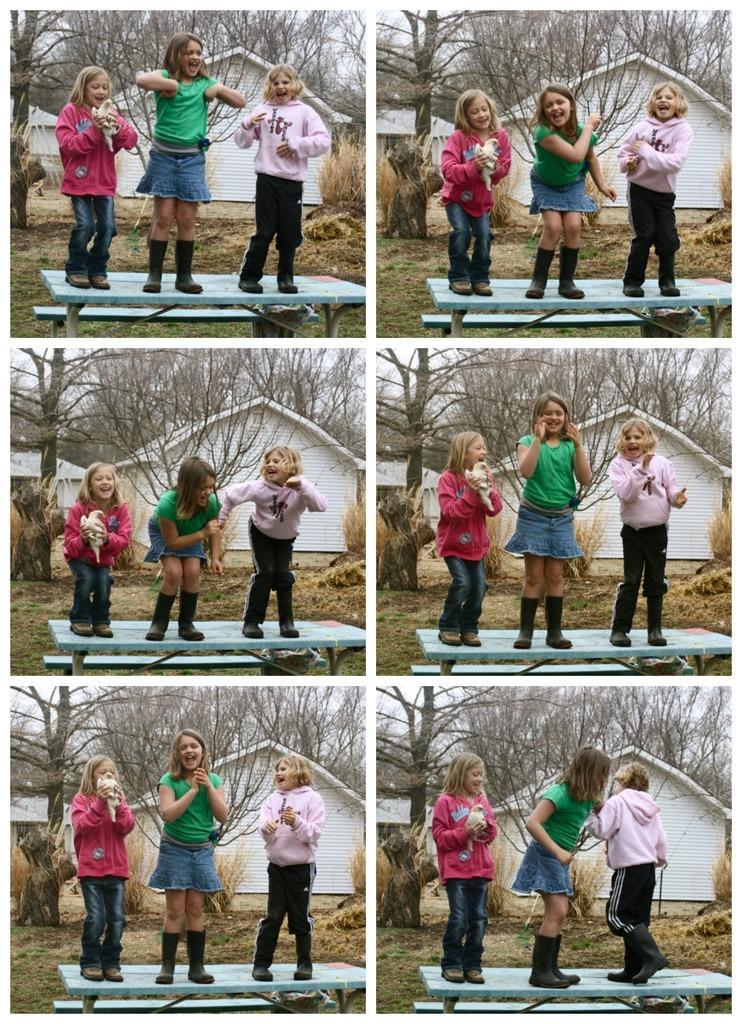Describe this image in one or two sentences. In the image we can see there are six photographs, In each photo there are three children standing on a bench and wearing clothes. These are the same photos with different actions, this is a house, white in color, dry grass and tree branches. The left corner girl is holding a pet in her hand, they are also wearing shoes. 